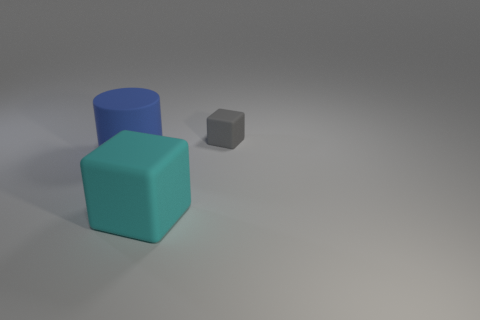Add 2 cyan objects. How many objects exist? 5 Subtract all large blue matte cylinders. Subtract all yellow matte cylinders. How many objects are left? 2 Add 3 gray matte things. How many gray matte things are left? 4 Add 3 large matte cylinders. How many large matte cylinders exist? 4 Subtract 0 red cylinders. How many objects are left? 3 Subtract all cubes. How many objects are left? 1 